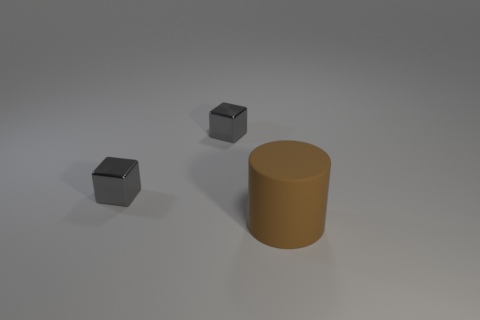Add 2 small blocks. How many objects exist? 5 Subtract all cylinders. How many objects are left? 2 Add 2 large cylinders. How many large cylinders are left? 3 Add 2 metal things. How many metal things exist? 4 Subtract 1 gray cubes. How many objects are left? 2 Subtract all big yellow matte cylinders. Subtract all big brown rubber cylinders. How many objects are left? 2 